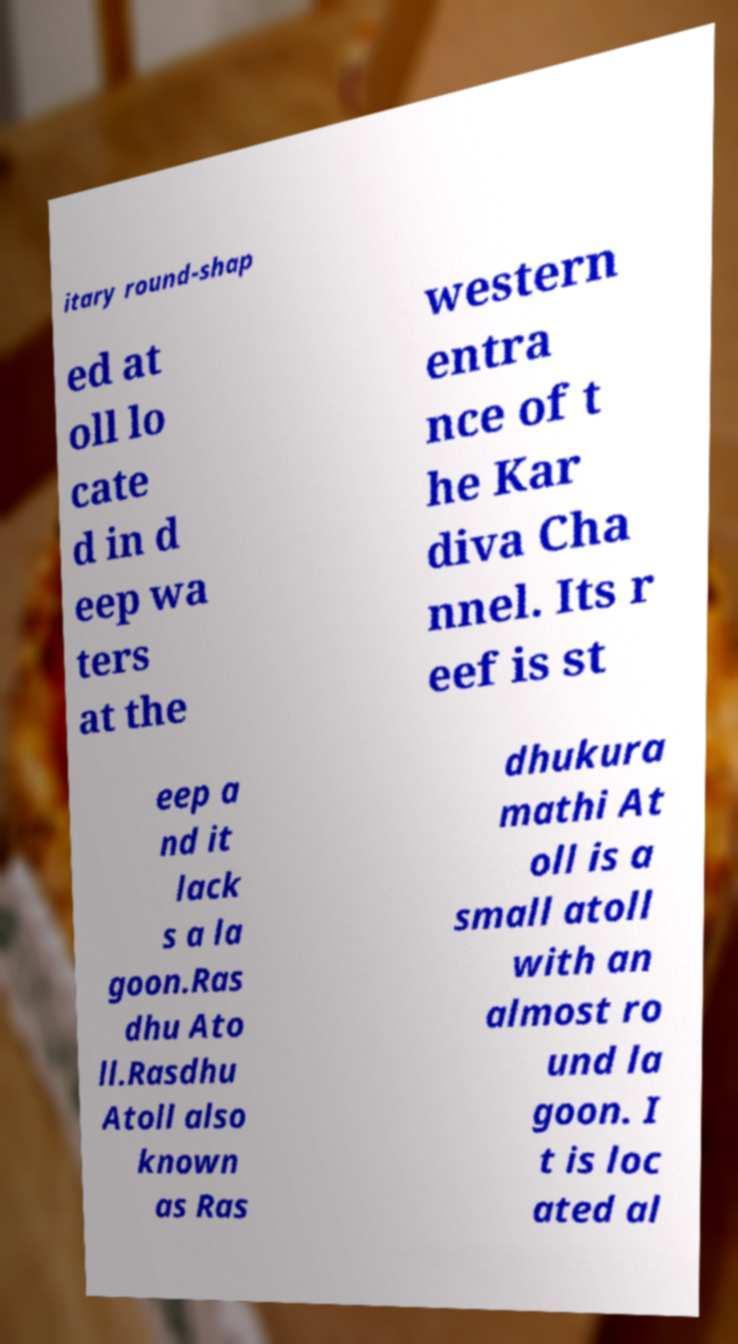What messages or text are displayed in this image? I need them in a readable, typed format. itary round-shap ed at oll lo cate d in d eep wa ters at the western entra nce of t he Kar diva Cha nnel. Its r eef is st eep a nd it lack s a la goon.Ras dhu Ato ll.Rasdhu Atoll also known as Ras dhukura mathi At oll is a small atoll with an almost ro und la goon. I t is loc ated al 